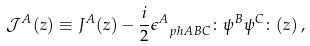<formula> <loc_0><loc_0><loc_500><loc_500>\mathcal { J } ^ { A } ( z ) \equiv J ^ { A } ( z ) - \frac { i } { 2 } \epsilon ^ { A } _ { \ p h { A } B C } \colon \psi ^ { B } \psi ^ { C } \colon ( z ) \, ,</formula> 